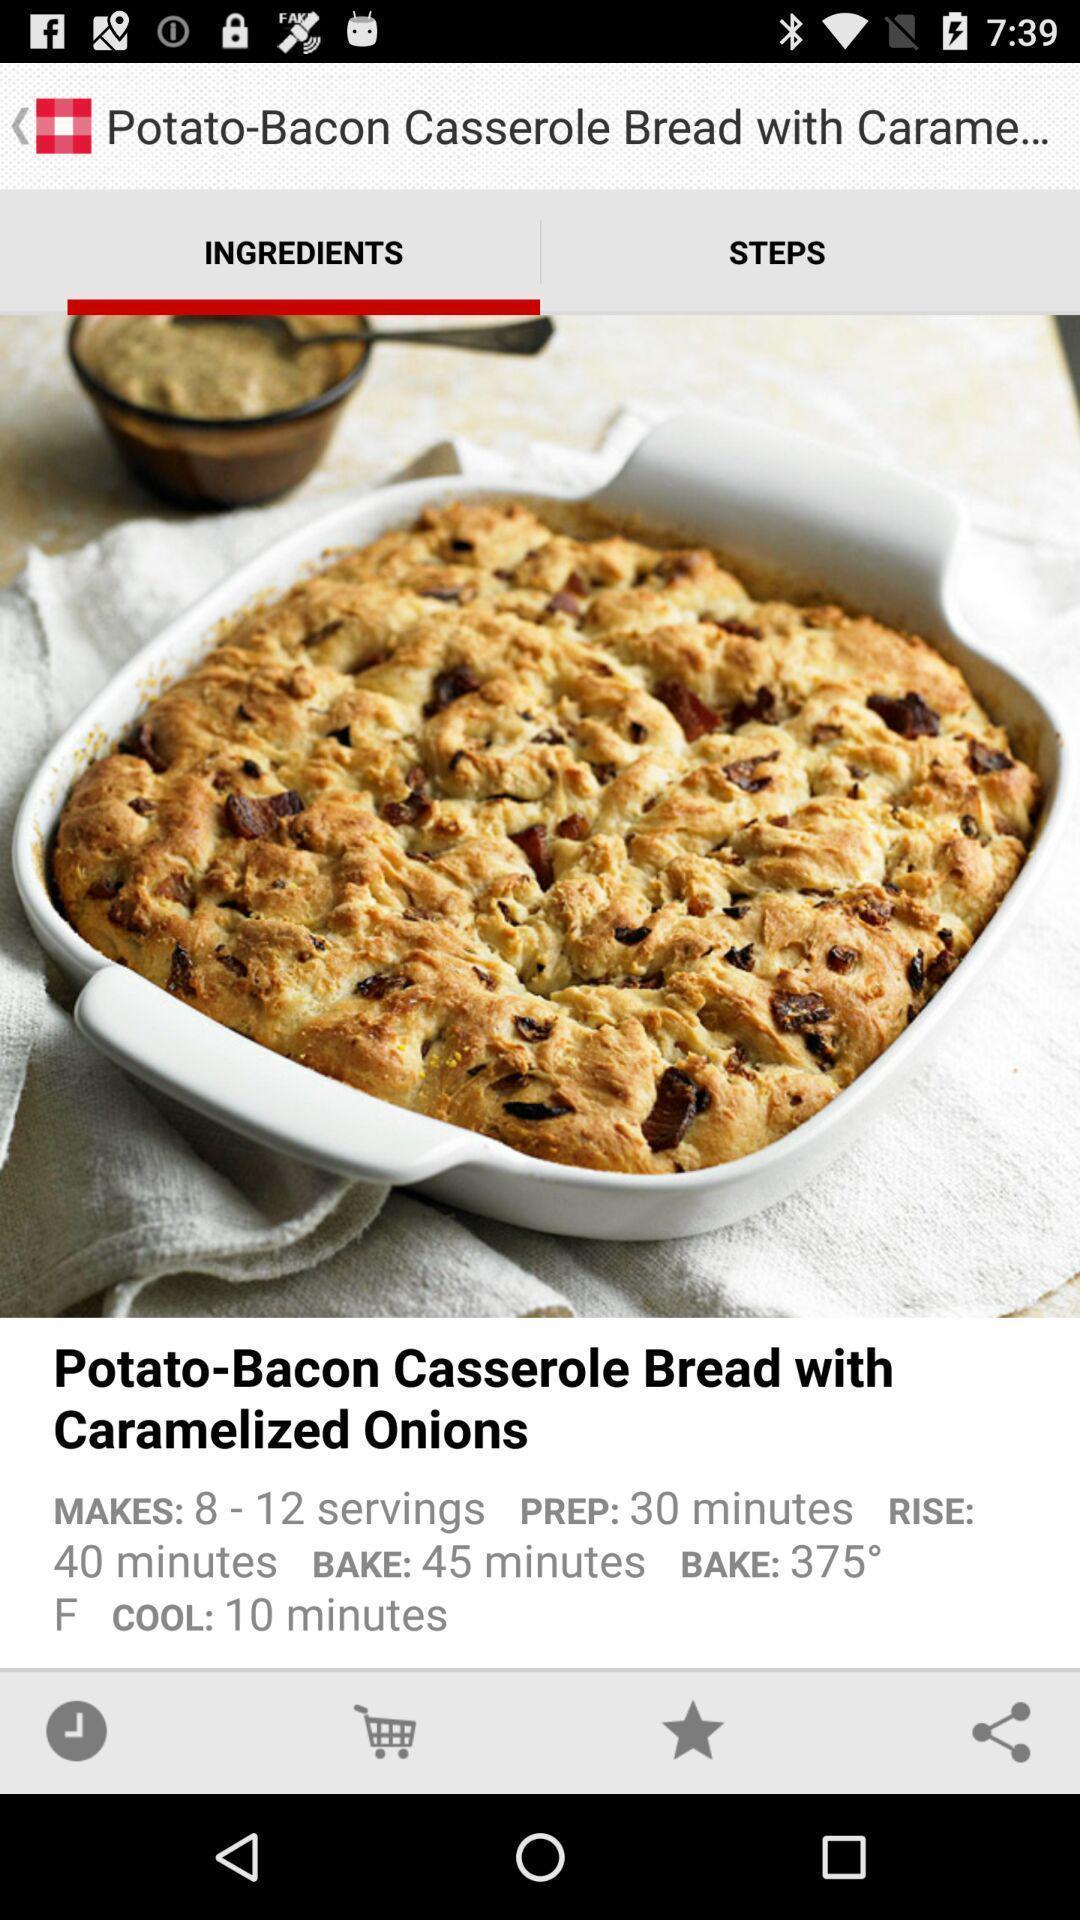Explain the elements present in this screenshot. Page showing recipe in cooking app. 